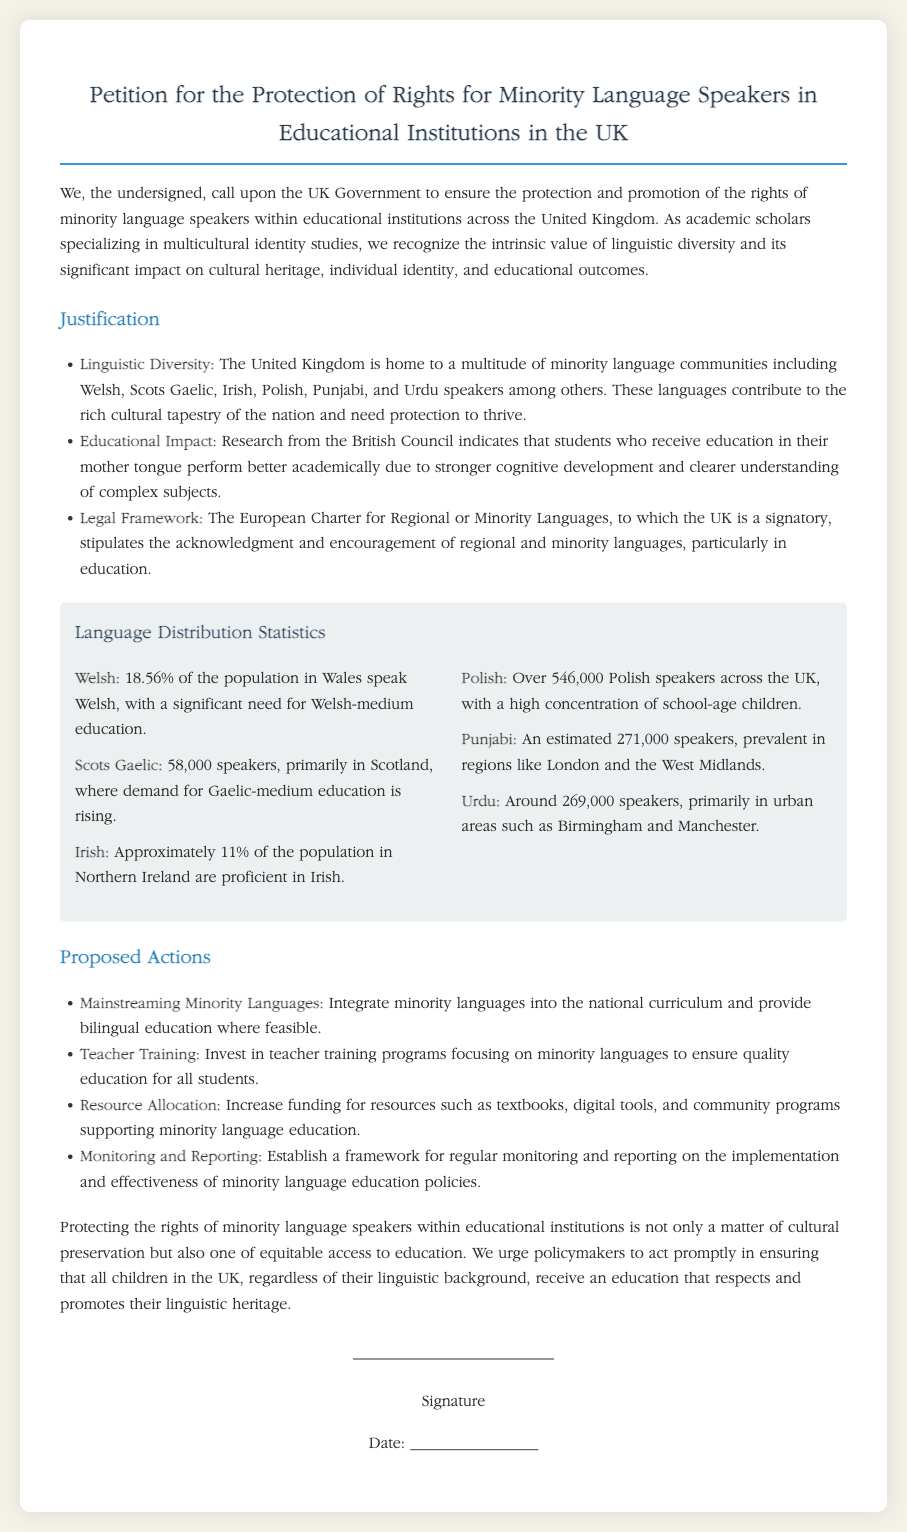What percentage of the population in Wales speaks Welsh? The document states that 18.56% of the population in Wales speak Welsh.
Answer: 18.56% How many speakers of Scots Gaelic are there? The document mentions that there are 58,000 speakers of Scots Gaelic.
Answer: 58,000 What is one proposed action regarding teacher training? The document states one proposed action is to invest in teacher training programs focusing on minority languages.
Answer: Invest in teacher training What is the estimated number of Polish speakers across the UK? The document indicates that there are over 546,000 Polish speakers across the UK.
Answer: Over 546,000 What is the main purpose of the petition? The main purpose of the petition is to ensure the protection and promotion of the rights of minority language speakers in educational institutions.
Answer: Protection and promotion of rights What languages are mentioned as minority languages in the UK? The document lists Welsh, Scots Gaelic, Irish, Polish, Punjabi, and Urdu as minority languages.
Answer: Welsh, Scots Gaelic, Irish, Polish, Punjabi, Urdu What demographic is highlighted as needing Welsh-medium education? The document specifies that there is a significant need for Welsh-medium education among the population in Wales.
Answer: Population in Wales Which legal framework is referenced in the document? The document refers to the European Charter for Regional or Minority Languages.
Answer: European Charter for Regional or Minority Languages 